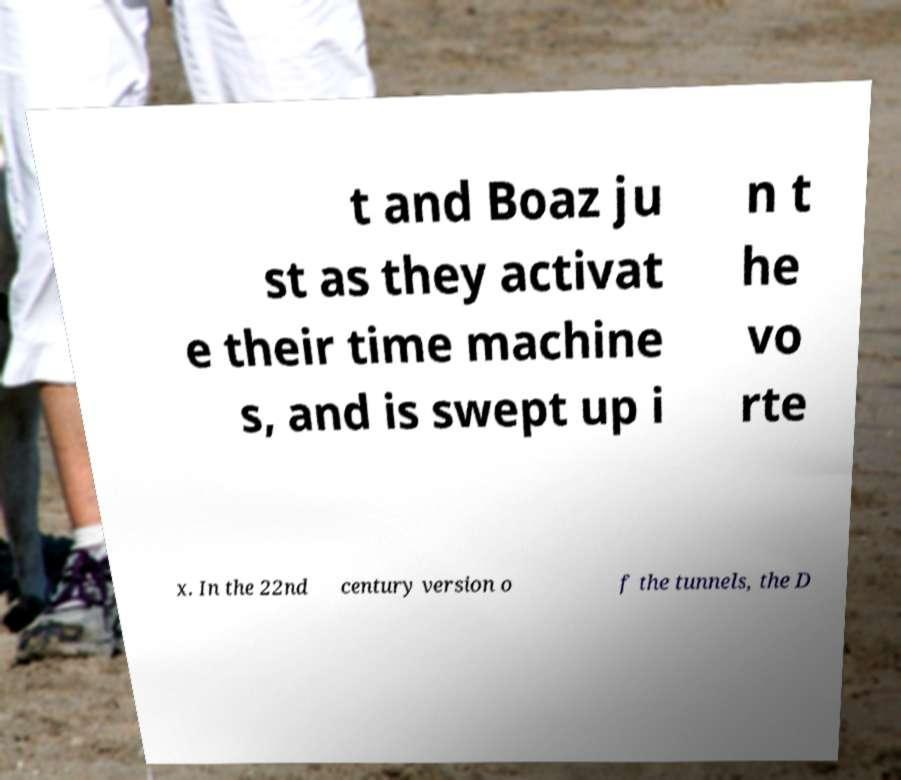Please identify and transcribe the text found in this image. t and Boaz ju st as they activat e their time machine s, and is swept up i n t he vo rte x. In the 22nd century version o f the tunnels, the D 